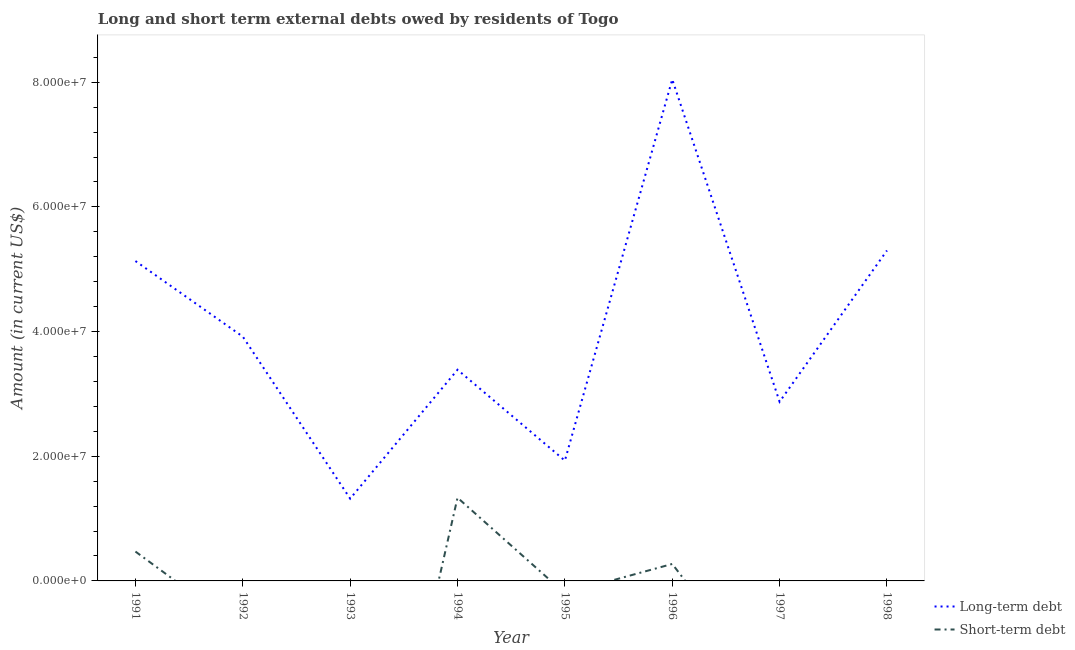How many different coloured lines are there?
Keep it short and to the point. 2. What is the long-term debts owed by residents in 1997?
Provide a succinct answer. 2.87e+07. Across all years, what is the maximum short-term debts owed by residents?
Your response must be concise. 1.34e+07. In which year was the long-term debts owed by residents maximum?
Keep it short and to the point. 1996. What is the total long-term debts owed by residents in the graph?
Offer a very short reply. 3.19e+08. What is the difference between the long-term debts owed by residents in 1995 and that in 1997?
Your answer should be compact. -9.44e+06. What is the difference between the long-term debts owed by residents in 1998 and the short-term debts owed by residents in 1993?
Provide a short and direct response. 5.30e+07. What is the average long-term debts owed by residents per year?
Your answer should be very brief. 3.99e+07. In the year 1996, what is the difference between the long-term debts owed by residents and short-term debts owed by residents?
Give a very brief answer. 7.77e+07. In how many years, is the long-term debts owed by residents greater than 60000000 US$?
Keep it short and to the point. 1. What is the ratio of the long-term debts owed by residents in 1996 to that in 1997?
Ensure brevity in your answer.  2.8. Is the difference between the short-term debts owed by residents in 1994 and 1996 greater than the difference between the long-term debts owed by residents in 1994 and 1996?
Your answer should be compact. Yes. What is the difference between the highest and the second highest long-term debts owed by residents?
Offer a very short reply. 2.74e+07. What is the difference between the highest and the lowest short-term debts owed by residents?
Your answer should be very brief. 1.34e+07. Is the sum of the long-term debts owed by residents in 1992 and 1994 greater than the maximum short-term debts owed by residents across all years?
Keep it short and to the point. Yes. Does the short-term debts owed by residents monotonically increase over the years?
Your response must be concise. No. Is the short-term debts owed by residents strictly greater than the long-term debts owed by residents over the years?
Provide a succinct answer. No. How many years are there in the graph?
Offer a terse response. 8. Does the graph contain any zero values?
Provide a succinct answer. Yes. Does the graph contain grids?
Ensure brevity in your answer.  No. Where does the legend appear in the graph?
Give a very brief answer. Bottom right. How many legend labels are there?
Provide a succinct answer. 2. How are the legend labels stacked?
Your answer should be compact. Vertical. What is the title of the graph?
Provide a short and direct response. Long and short term external debts owed by residents of Togo. Does "Old" appear as one of the legend labels in the graph?
Offer a very short reply. No. What is the Amount (in current US$) in Long-term debt in 1991?
Offer a very short reply. 5.13e+07. What is the Amount (in current US$) in Short-term debt in 1991?
Ensure brevity in your answer.  4.71e+06. What is the Amount (in current US$) of Long-term debt in 1992?
Make the answer very short. 3.92e+07. What is the Amount (in current US$) of Long-term debt in 1993?
Offer a very short reply. 1.32e+07. What is the Amount (in current US$) of Short-term debt in 1993?
Offer a very short reply. 0. What is the Amount (in current US$) in Long-term debt in 1994?
Keep it short and to the point. 3.39e+07. What is the Amount (in current US$) in Short-term debt in 1994?
Your answer should be very brief. 1.34e+07. What is the Amount (in current US$) in Long-term debt in 1995?
Provide a succinct answer. 1.93e+07. What is the Amount (in current US$) in Long-term debt in 1996?
Your answer should be very brief. 8.05e+07. What is the Amount (in current US$) in Short-term debt in 1996?
Your response must be concise. 2.72e+06. What is the Amount (in current US$) of Long-term debt in 1997?
Your answer should be very brief. 2.87e+07. What is the Amount (in current US$) of Long-term debt in 1998?
Make the answer very short. 5.30e+07. Across all years, what is the maximum Amount (in current US$) in Long-term debt?
Your answer should be compact. 8.05e+07. Across all years, what is the maximum Amount (in current US$) in Short-term debt?
Keep it short and to the point. 1.34e+07. Across all years, what is the minimum Amount (in current US$) in Long-term debt?
Your response must be concise. 1.32e+07. Across all years, what is the minimum Amount (in current US$) of Short-term debt?
Provide a short and direct response. 0. What is the total Amount (in current US$) in Long-term debt in the graph?
Provide a short and direct response. 3.19e+08. What is the total Amount (in current US$) in Short-term debt in the graph?
Offer a terse response. 2.08e+07. What is the difference between the Amount (in current US$) of Long-term debt in 1991 and that in 1992?
Your answer should be compact. 1.21e+07. What is the difference between the Amount (in current US$) of Long-term debt in 1991 and that in 1993?
Your response must be concise. 3.81e+07. What is the difference between the Amount (in current US$) of Long-term debt in 1991 and that in 1994?
Provide a short and direct response. 1.74e+07. What is the difference between the Amount (in current US$) of Short-term debt in 1991 and that in 1994?
Keep it short and to the point. -8.64e+06. What is the difference between the Amount (in current US$) of Long-term debt in 1991 and that in 1995?
Keep it short and to the point. 3.20e+07. What is the difference between the Amount (in current US$) in Long-term debt in 1991 and that in 1996?
Provide a short and direct response. -2.91e+07. What is the difference between the Amount (in current US$) of Short-term debt in 1991 and that in 1996?
Your response must be concise. 1.99e+06. What is the difference between the Amount (in current US$) in Long-term debt in 1991 and that in 1997?
Keep it short and to the point. 2.26e+07. What is the difference between the Amount (in current US$) in Long-term debt in 1991 and that in 1998?
Your response must be concise. -1.69e+06. What is the difference between the Amount (in current US$) of Long-term debt in 1992 and that in 1993?
Provide a short and direct response. 2.60e+07. What is the difference between the Amount (in current US$) of Long-term debt in 1992 and that in 1994?
Make the answer very short. 5.31e+06. What is the difference between the Amount (in current US$) of Long-term debt in 1992 and that in 1995?
Provide a succinct answer. 1.99e+07. What is the difference between the Amount (in current US$) of Long-term debt in 1992 and that in 1996?
Make the answer very short. -4.13e+07. What is the difference between the Amount (in current US$) of Long-term debt in 1992 and that in 1997?
Provide a succinct answer. 1.04e+07. What is the difference between the Amount (in current US$) in Long-term debt in 1992 and that in 1998?
Make the answer very short. -1.38e+07. What is the difference between the Amount (in current US$) of Long-term debt in 1993 and that in 1994?
Give a very brief answer. -2.07e+07. What is the difference between the Amount (in current US$) in Long-term debt in 1993 and that in 1995?
Your answer should be compact. -6.10e+06. What is the difference between the Amount (in current US$) in Long-term debt in 1993 and that in 1996?
Provide a succinct answer. -6.73e+07. What is the difference between the Amount (in current US$) of Long-term debt in 1993 and that in 1997?
Offer a terse response. -1.55e+07. What is the difference between the Amount (in current US$) in Long-term debt in 1993 and that in 1998?
Keep it short and to the point. -3.98e+07. What is the difference between the Amount (in current US$) in Long-term debt in 1994 and that in 1995?
Provide a succinct answer. 1.46e+07. What is the difference between the Amount (in current US$) of Long-term debt in 1994 and that in 1996?
Your response must be concise. -4.66e+07. What is the difference between the Amount (in current US$) in Short-term debt in 1994 and that in 1996?
Keep it short and to the point. 1.06e+07. What is the difference between the Amount (in current US$) in Long-term debt in 1994 and that in 1997?
Keep it short and to the point. 5.13e+06. What is the difference between the Amount (in current US$) of Long-term debt in 1994 and that in 1998?
Provide a succinct answer. -1.91e+07. What is the difference between the Amount (in current US$) of Long-term debt in 1995 and that in 1996?
Offer a very short reply. -6.12e+07. What is the difference between the Amount (in current US$) in Long-term debt in 1995 and that in 1997?
Keep it short and to the point. -9.44e+06. What is the difference between the Amount (in current US$) of Long-term debt in 1995 and that in 1998?
Keep it short and to the point. -3.37e+07. What is the difference between the Amount (in current US$) in Long-term debt in 1996 and that in 1997?
Provide a short and direct response. 5.17e+07. What is the difference between the Amount (in current US$) in Long-term debt in 1996 and that in 1998?
Your response must be concise. 2.74e+07. What is the difference between the Amount (in current US$) of Long-term debt in 1997 and that in 1998?
Keep it short and to the point. -2.43e+07. What is the difference between the Amount (in current US$) in Long-term debt in 1991 and the Amount (in current US$) in Short-term debt in 1994?
Provide a short and direct response. 3.80e+07. What is the difference between the Amount (in current US$) of Long-term debt in 1991 and the Amount (in current US$) of Short-term debt in 1996?
Give a very brief answer. 4.86e+07. What is the difference between the Amount (in current US$) of Long-term debt in 1992 and the Amount (in current US$) of Short-term debt in 1994?
Offer a terse response. 2.58e+07. What is the difference between the Amount (in current US$) of Long-term debt in 1992 and the Amount (in current US$) of Short-term debt in 1996?
Give a very brief answer. 3.65e+07. What is the difference between the Amount (in current US$) of Long-term debt in 1993 and the Amount (in current US$) of Short-term debt in 1994?
Provide a succinct answer. -1.48e+05. What is the difference between the Amount (in current US$) in Long-term debt in 1993 and the Amount (in current US$) in Short-term debt in 1996?
Give a very brief answer. 1.05e+07. What is the difference between the Amount (in current US$) in Long-term debt in 1994 and the Amount (in current US$) in Short-term debt in 1996?
Provide a short and direct response. 3.12e+07. What is the difference between the Amount (in current US$) in Long-term debt in 1995 and the Amount (in current US$) in Short-term debt in 1996?
Provide a succinct answer. 1.66e+07. What is the average Amount (in current US$) in Long-term debt per year?
Provide a succinct answer. 3.99e+07. What is the average Amount (in current US$) in Short-term debt per year?
Offer a very short reply. 2.60e+06. In the year 1991, what is the difference between the Amount (in current US$) in Long-term debt and Amount (in current US$) in Short-term debt?
Your response must be concise. 4.66e+07. In the year 1994, what is the difference between the Amount (in current US$) in Long-term debt and Amount (in current US$) in Short-term debt?
Offer a very short reply. 2.05e+07. In the year 1996, what is the difference between the Amount (in current US$) in Long-term debt and Amount (in current US$) in Short-term debt?
Provide a short and direct response. 7.77e+07. What is the ratio of the Amount (in current US$) of Long-term debt in 1991 to that in 1992?
Provide a succinct answer. 1.31. What is the ratio of the Amount (in current US$) of Long-term debt in 1991 to that in 1993?
Give a very brief answer. 3.89. What is the ratio of the Amount (in current US$) in Long-term debt in 1991 to that in 1994?
Your answer should be very brief. 1.51. What is the ratio of the Amount (in current US$) in Short-term debt in 1991 to that in 1994?
Your answer should be very brief. 0.35. What is the ratio of the Amount (in current US$) in Long-term debt in 1991 to that in 1995?
Make the answer very short. 2.66. What is the ratio of the Amount (in current US$) of Long-term debt in 1991 to that in 1996?
Offer a terse response. 0.64. What is the ratio of the Amount (in current US$) in Short-term debt in 1991 to that in 1996?
Provide a succinct answer. 1.73. What is the ratio of the Amount (in current US$) of Long-term debt in 1991 to that in 1997?
Offer a terse response. 1.79. What is the ratio of the Amount (in current US$) in Long-term debt in 1991 to that in 1998?
Offer a very short reply. 0.97. What is the ratio of the Amount (in current US$) in Long-term debt in 1992 to that in 1993?
Give a very brief answer. 2.97. What is the ratio of the Amount (in current US$) of Long-term debt in 1992 to that in 1994?
Your response must be concise. 1.16. What is the ratio of the Amount (in current US$) of Long-term debt in 1992 to that in 1995?
Ensure brevity in your answer.  2.03. What is the ratio of the Amount (in current US$) of Long-term debt in 1992 to that in 1996?
Provide a succinct answer. 0.49. What is the ratio of the Amount (in current US$) of Long-term debt in 1992 to that in 1997?
Ensure brevity in your answer.  1.36. What is the ratio of the Amount (in current US$) of Long-term debt in 1992 to that in 1998?
Ensure brevity in your answer.  0.74. What is the ratio of the Amount (in current US$) of Long-term debt in 1993 to that in 1994?
Make the answer very short. 0.39. What is the ratio of the Amount (in current US$) in Long-term debt in 1993 to that in 1995?
Provide a succinct answer. 0.68. What is the ratio of the Amount (in current US$) in Long-term debt in 1993 to that in 1996?
Give a very brief answer. 0.16. What is the ratio of the Amount (in current US$) of Long-term debt in 1993 to that in 1997?
Give a very brief answer. 0.46. What is the ratio of the Amount (in current US$) in Long-term debt in 1993 to that in 1998?
Offer a very short reply. 0.25. What is the ratio of the Amount (in current US$) in Long-term debt in 1994 to that in 1995?
Offer a very short reply. 1.76. What is the ratio of the Amount (in current US$) of Long-term debt in 1994 to that in 1996?
Your response must be concise. 0.42. What is the ratio of the Amount (in current US$) of Short-term debt in 1994 to that in 1996?
Your response must be concise. 4.91. What is the ratio of the Amount (in current US$) in Long-term debt in 1994 to that in 1997?
Your response must be concise. 1.18. What is the ratio of the Amount (in current US$) in Long-term debt in 1994 to that in 1998?
Ensure brevity in your answer.  0.64. What is the ratio of the Amount (in current US$) in Long-term debt in 1995 to that in 1996?
Provide a short and direct response. 0.24. What is the ratio of the Amount (in current US$) of Long-term debt in 1995 to that in 1997?
Provide a succinct answer. 0.67. What is the ratio of the Amount (in current US$) of Long-term debt in 1995 to that in 1998?
Provide a short and direct response. 0.36. What is the ratio of the Amount (in current US$) of Long-term debt in 1996 to that in 1997?
Offer a terse response. 2.8. What is the ratio of the Amount (in current US$) of Long-term debt in 1996 to that in 1998?
Provide a succinct answer. 1.52. What is the ratio of the Amount (in current US$) of Long-term debt in 1997 to that in 1998?
Provide a short and direct response. 0.54. What is the difference between the highest and the second highest Amount (in current US$) in Long-term debt?
Make the answer very short. 2.74e+07. What is the difference between the highest and the second highest Amount (in current US$) in Short-term debt?
Your answer should be very brief. 8.64e+06. What is the difference between the highest and the lowest Amount (in current US$) of Long-term debt?
Offer a very short reply. 6.73e+07. What is the difference between the highest and the lowest Amount (in current US$) in Short-term debt?
Your answer should be very brief. 1.34e+07. 